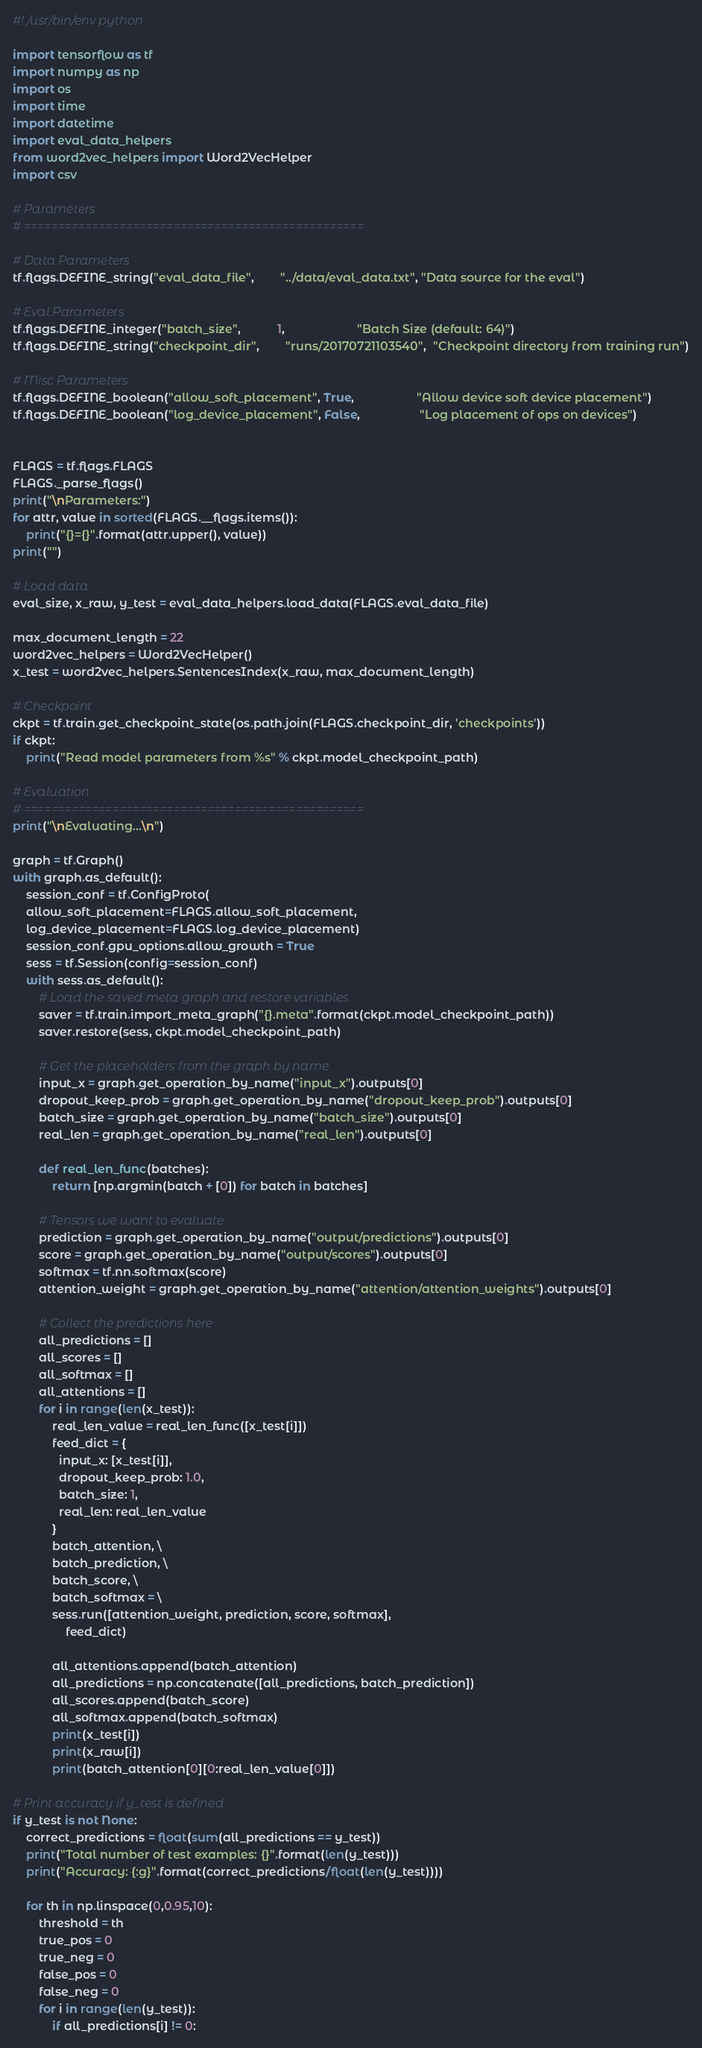Convert code to text. <code><loc_0><loc_0><loc_500><loc_500><_Python_>#! /usr/bin/env python

import tensorflow as tf
import numpy as np
import os
import time
import datetime
import eval_data_helpers
from word2vec_helpers import Word2VecHelper
import csv

# Parameters
# ==================================================

# Data Parameters
tf.flags.DEFINE_string("eval_data_file",        "../data/eval_data.txt", "Data source for the eval")

# Eval Parameters
tf.flags.DEFINE_integer("batch_size",           1,                      "Batch Size (default: 64)")
tf.flags.DEFINE_string("checkpoint_dir",        "runs/20170721103540",  "Checkpoint directory from training run")

# Misc Parameters
tf.flags.DEFINE_boolean("allow_soft_placement", True,                   "Allow device soft device placement")
tf.flags.DEFINE_boolean("log_device_placement", False,                  "Log placement of ops on devices")


FLAGS = tf.flags.FLAGS
FLAGS._parse_flags()
print("\nParameters:")
for attr, value in sorted(FLAGS.__flags.items()):
    print("{}={}".format(attr.upper(), value))
print("")

# Load data
eval_size, x_raw, y_test = eval_data_helpers.load_data(FLAGS.eval_data_file)

max_document_length = 22
word2vec_helpers = Word2VecHelper()
x_test = word2vec_helpers.SentencesIndex(x_raw, max_document_length)

# Checkpoint
ckpt = tf.train.get_checkpoint_state(os.path.join(FLAGS.checkpoint_dir, 'checkpoints'))
if ckpt:
    print("Read model parameters from %s" % ckpt.model_checkpoint_path)

# Evaluation
# ==================================================
print("\nEvaluating...\n")

graph = tf.Graph()
with graph.as_default():
    session_conf = tf.ConfigProto(
    allow_soft_placement=FLAGS.allow_soft_placement,
    log_device_placement=FLAGS.log_device_placement)
    session_conf.gpu_options.allow_growth = True
    sess = tf.Session(config=session_conf)
    with sess.as_default():
        # Load the saved meta graph and restore variables
        saver = tf.train.import_meta_graph("{}.meta".format(ckpt.model_checkpoint_path))
        saver.restore(sess, ckpt.model_checkpoint_path)

        # Get the placeholders from the graph by name
        input_x = graph.get_operation_by_name("input_x").outputs[0]
        dropout_keep_prob = graph.get_operation_by_name("dropout_keep_prob").outputs[0]
        batch_size = graph.get_operation_by_name("batch_size").outputs[0]
        real_len = graph.get_operation_by_name("real_len").outputs[0]

        def real_len_func(batches):
            return [np.argmin(batch + [0]) for batch in batches]

        # Tensors we want to evaluate
        prediction = graph.get_operation_by_name("output/predictions").outputs[0]
        score = graph.get_operation_by_name("output/scores").outputs[0]
        softmax = tf.nn.softmax(score)
        attention_weight = graph.get_operation_by_name("attention/attention_weights").outputs[0]
        
        # Collect the predictions here
        all_predictions = []
        all_scores = []
        all_softmax = []
        all_attentions = []
        for i in range(len(x_test)):
            real_len_value = real_len_func([x_test[i]])
            feed_dict = {
              input_x: [x_test[i]],
              dropout_keep_prob: 1.0,
              batch_size: 1,
              real_len: real_len_value
            }
            batch_attention, \
            batch_prediction, \
            batch_score, \
            batch_softmax = \
            sess.run([attention_weight, prediction, score, softmax], 
                feed_dict)

            all_attentions.append(batch_attention)
            all_predictions = np.concatenate([all_predictions, batch_prediction])
            all_scores.append(batch_score)
            all_softmax.append(batch_softmax)
            print(x_test[i])
            print(x_raw[i])
            print(batch_attention[0][0:real_len_value[0]])

# Print accuracy if y_test is defined
if y_test is not None:
    correct_predictions = float(sum(all_predictions == y_test))
    print("Total number of test examples: {}".format(len(y_test)))
    print("Accuracy: {:g}".format(correct_predictions/float(len(y_test))))

    for th in np.linspace(0,0.95,10):
        threshold = th
        true_pos = 0
        true_neg = 0
        false_pos = 0
        false_neg = 0
        for i in range(len(y_test)):
            if all_predictions[i] != 0:</code> 